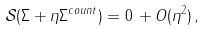<formula> <loc_0><loc_0><loc_500><loc_500>\mathcal { S } ( \Sigma + \eta \Sigma ^ { c o u n t } ) = 0 \, + O ( \eta ^ { 2 } ) \, ,</formula> 